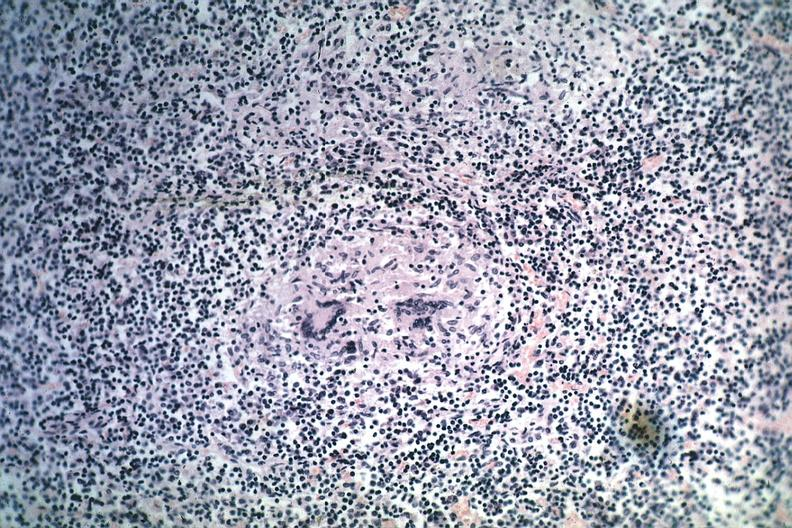s exposure present?
Answer the question using a single word or phrase. No 